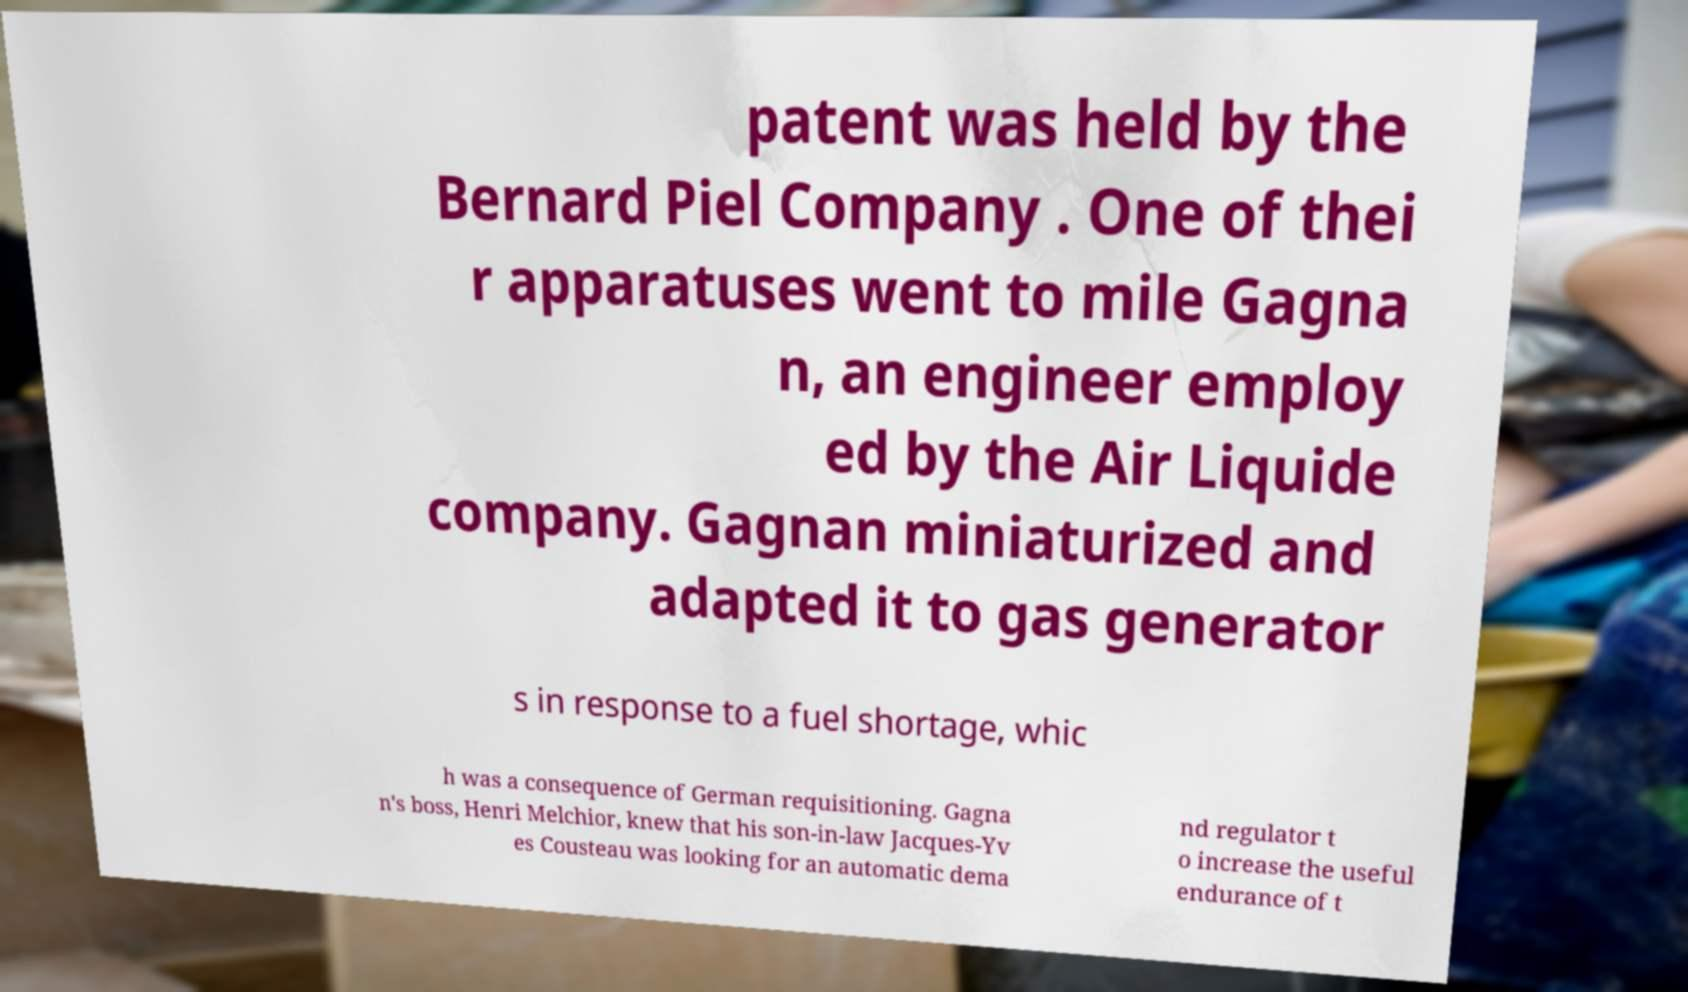Could you assist in decoding the text presented in this image and type it out clearly? patent was held by the Bernard Piel Company . One of thei r apparatuses went to mile Gagna n, an engineer employ ed by the Air Liquide company. Gagnan miniaturized and adapted it to gas generator s in response to a fuel shortage, whic h was a consequence of German requisitioning. Gagna n's boss, Henri Melchior, knew that his son-in-law Jacques-Yv es Cousteau was looking for an automatic dema nd regulator t o increase the useful endurance of t 